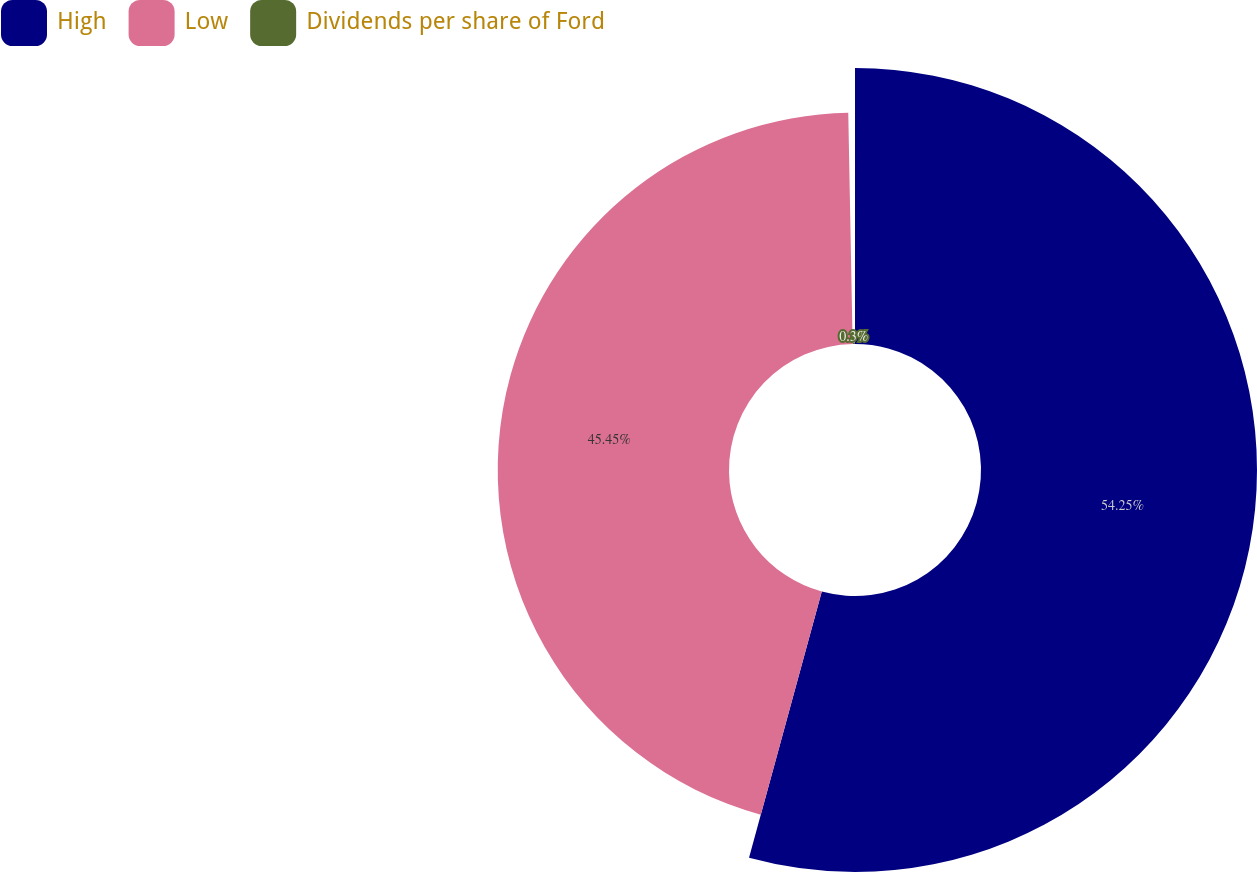Convert chart. <chart><loc_0><loc_0><loc_500><loc_500><pie_chart><fcel>High<fcel>Low<fcel>Dividends per share of Ford<nl><fcel>54.24%<fcel>45.45%<fcel>0.3%<nl></chart> 